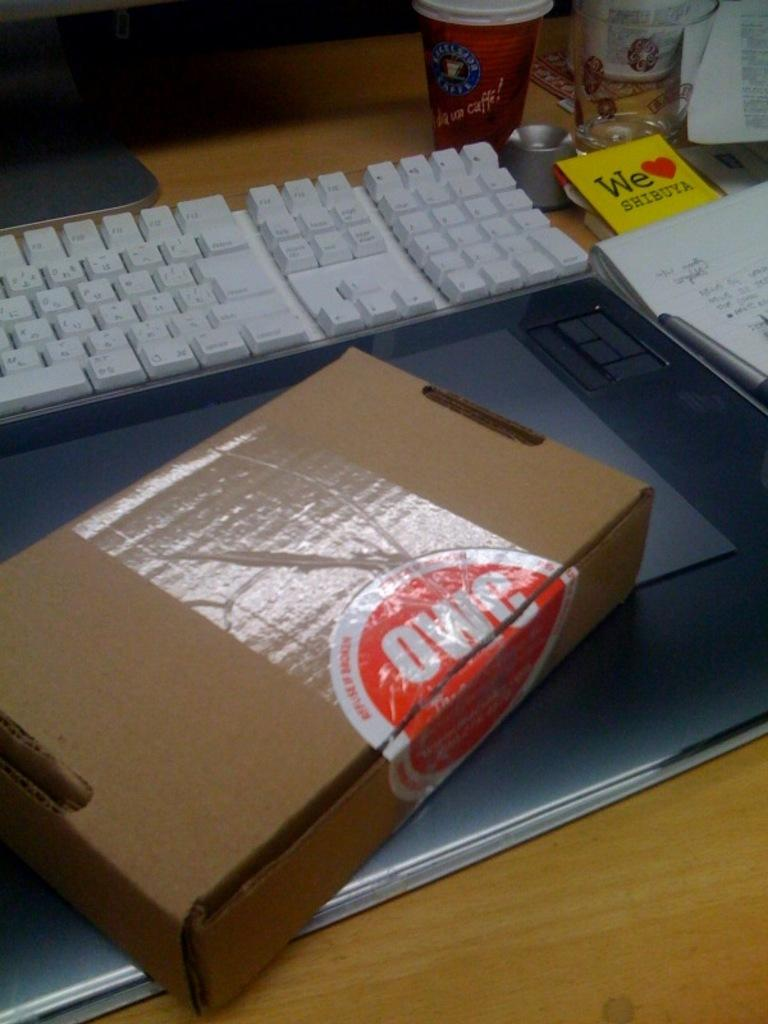<image>
Write a terse but informative summary of the picture. A package is displayed from a company titled OWC. 